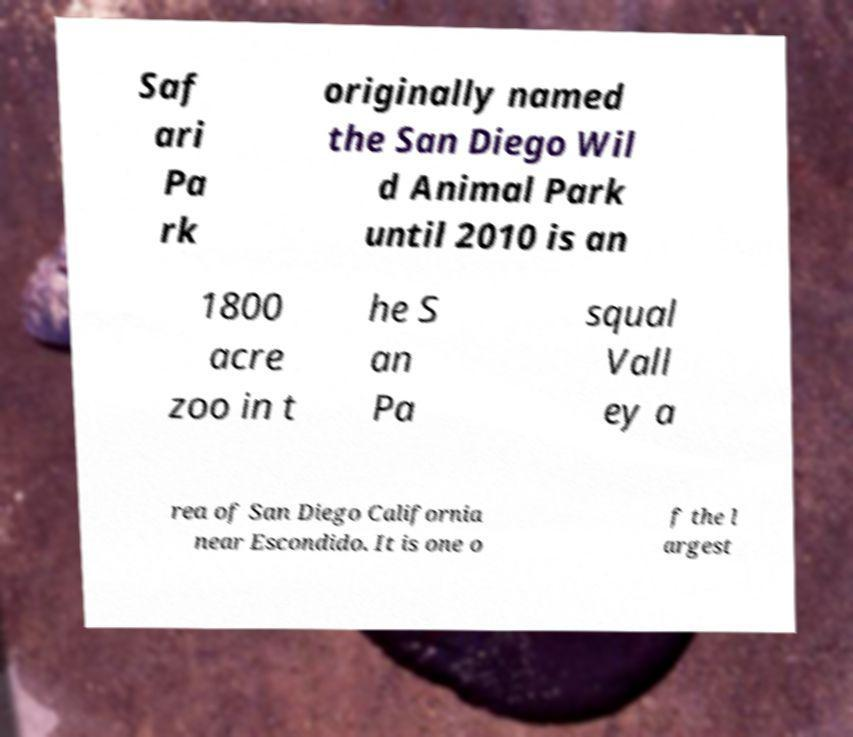Can you read and provide the text displayed in the image?This photo seems to have some interesting text. Can you extract and type it out for me? Saf ari Pa rk originally named the San Diego Wil d Animal Park until 2010 is an 1800 acre zoo in t he S an Pa squal Vall ey a rea of San Diego California near Escondido. It is one o f the l argest 